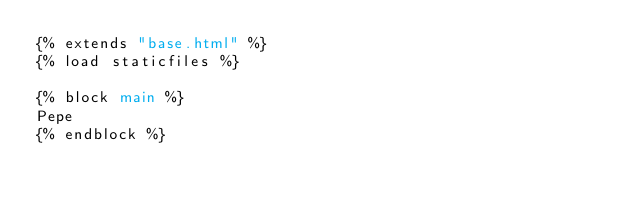Convert code to text. <code><loc_0><loc_0><loc_500><loc_500><_HTML_>{% extends "base.html" %}
{% load staticfiles %}

{% block main %}
Pepe
{% endblock %}</code> 